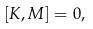Convert formula to latex. <formula><loc_0><loc_0><loc_500><loc_500>[ K , M ] = 0 ,</formula> 